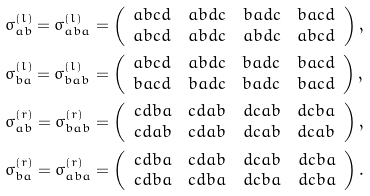<formula> <loc_0><loc_0><loc_500><loc_500>& \sigma _ { a b } ^ { ( l ) } = \sigma _ { a b a } ^ { ( l ) } = \left ( \begin{array} { l l l l } a b c d & a b d c & b a d c & b a c d \\ a b c d & a b d c & a b d c & a b c d \end{array} \right ) , \\ & \sigma _ { b a } ^ { ( l ) } = \sigma _ { b a b } ^ { ( l ) } = \left ( \begin{array} { l l l l } a b c d & a b d c & b a d c & b a c d \\ b a c d & b a d c & b a d c & b a c d \end{array} \right ) , \\ & \sigma _ { a b } ^ { ( r ) } = \sigma _ { b a b } ^ { ( r ) } = \left ( \begin{array} { l l l l } c d b a & c d a b & d c a b & d c b a \\ c d a b & c d a b & d c a b & d c a b \end{array} \right ) , \\ & \sigma _ { b a } ^ { ( r ) } = \sigma _ { a b a } ^ { ( r ) } = \left ( \begin{array} { l l l l } c d b a & c d a b & d c a b & d c b a \\ c d b a & c d b a & d c b a & d c b a \end{array} \right ) .</formula> 